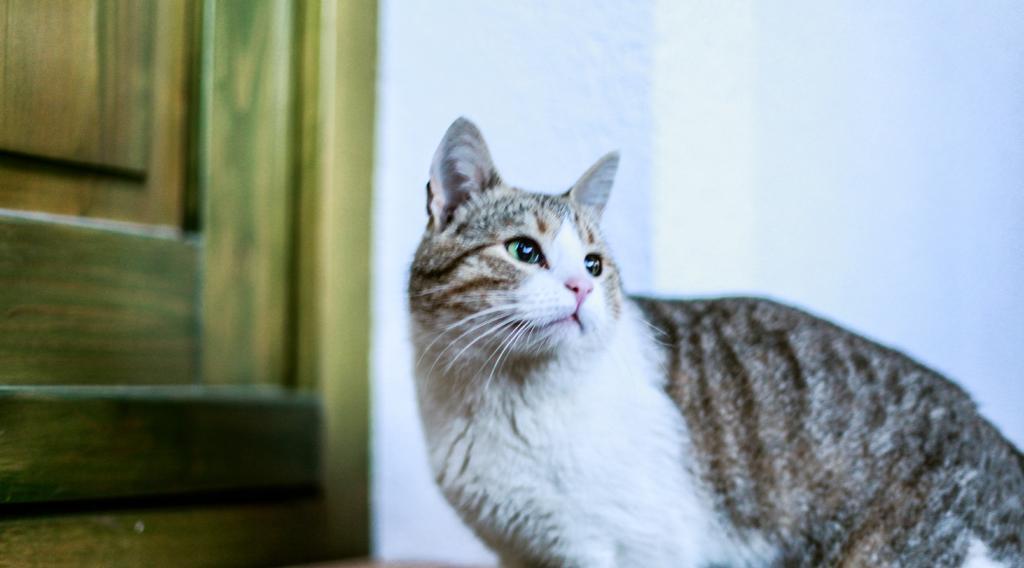In one or two sentences, can you explain what this image depicts? In this picture we can see a cat standing and looking at something, in the background there is a wall, we can see a door here. 